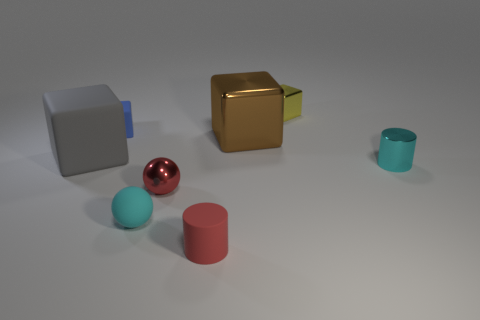Are there more tiny red cylinders in front of the red rubber object than cyan matte things?
Ensure brevity in your answer.  No. There is a small red cylinder; how many red things are behind it?
Make the answer very short. 1. There is a small rubber object that is the same color as the metallic sphere; what is its shape?
Make the answer very short. Cylinder. There is a tiny cube to the left of the cyan thing that is on the left side of the tiny cyan metal thing; are there any yellow metal things that are right of it?
Make the answer very short. Yes. Is the size of the red metal ball the same as the yellow metallic block?
Offer a terse response. Yes. Are there the same number of shiny cubes to the left of the yellow shiny cube and small cyan objects that are to the right of the large brown metallic cube?
Offer a very short reply. Yes. What shape is the cyan object to the left of the tiny yellow metal cube?
Offer a terse response. Sphere. There is a yellow shiny object that is the same size as the red metal sphere; what shape is it?
Give a very brief answer. Cube. There is a small cube in front of the small block that is to the right of the large metallic thing right of the small blue cube; what color is it?
Offer a terse response. Blue. Does the large brown object have the same shape as the tiny cyan rubber thing?
Your answer should be very brief. No. 